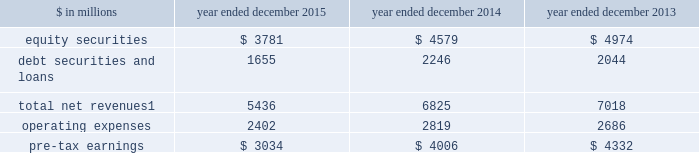The goldman sachs group , inc .
And subsidiaries management 2019s discussion and analysis investing & lending investing & lending includes our investing activities and the origination of loans to provide financing to clients .
These investments and loans are typically longer-term in nature .
We make investments , some of which are consolidated , directly and indirectly through funds and separate accounts that we manage , in debt securities and loans , public and private equity securities , and real estate entities .
The table below presents the operating results of our investing & lending segment. .
Net revenues related to our consolidated investments , previously reported in other net revenues within investing & lending , are now reported in equity securities and debt securities and loans , as results from these activities ( $ 391 million for 2015 ) are no longer significant principally due to the sale of metro in the fourth quarter of 2014 .
Reclassifications have been made to previously reported amounts to conform to the current presentation .
2015 versus 2014 .
Net revenues in investing & lending were $ 5.44 billion for 2015 , 20% ( 20 % ) lower than 2014 .
This decrease was primarily due to lower net revenues from investments in equities , principally reflecting the sale of metro in the fourth quarter of 2014 and lower net gains from investments in private equities , driven by corporate performance .
In addition , net revenues in debt securities and loans were significantly lower , reflecting lower net gains from investments .
Although net revenues in investing & lending for 2015 benefited from favorable company-specific events , including sales , initial public offerings and financings , a decline in global equity prices and widening high-yield credit spreads during the second half of the year impacted results .
Concern about the outlook for the global economy continues to be a meaningful consideration for the global marketplace .
If equity markets continue to decline or credit spreads widen further , net revenues in investing & lending would likely continue to be negatively impacted .
Operating expenses were $ 2.40 billion for 2015 , 15% ( 15 % ) lower than 2014 , due to lower depreciation and amortization expenses , primarily reflecting lower impairment charges related to consolidated investments , and a reduction in expenses related to the sale of metro in the fourth quarter of 2014 .
Pre-tax earnings were $ 3.03 billion in 2015 , 24% ( 24 % ) lower than 2014 .
2014 versus 2013 .
Net revenues in investing & lending were $ 6.83 billion for 2014 , 3% ( 3 % ) lower than 2013 .
Net revenues from investments in equity securities were lower due to a significant decrease in net gains from investments in public equities , as movements in global equity prices during 2014 were less favorable compared with 2013 , as well as significantly lower net revenues related to our consolidated investments , reflecting a decrease in operating revenues from commodities-related consolidated investments .
These decreases were partially offset by an increase in net gains from investments in private equities , primarily driven by company-specific events .
Net revenues from debt securities and loans were higher than 2013 , reflecting a significant increase in net interest income , primarily driven by increased lending , and a slight increase in net gains , primarily due to sales of certain investments during 2014 .
During 2014 , net revenues in investing & lending generally reflected favorable company-specific events , including initial public offerings and financings , and strong corporate performance , as well as net gains from sales of certain investments .
Operating expenses were $ 2.82 billion for 2014 , 5% ( 5 % ) higher than 2013 , reflecting higher compensation and benefits expenses , partially offset by lower expenses related to consolidated investments .
Pre-tax earnings were $ 4.01 billion in 2014 , 8% ( 8 % ) lower than 2013 .
64 goldman sachs 2015 form 10-k .
What percentage of total net revenues in the investing & lending segment is attributable to equity securities in 2014? 
Computations: (4579 / 6825)
Answer: 0.67092. 